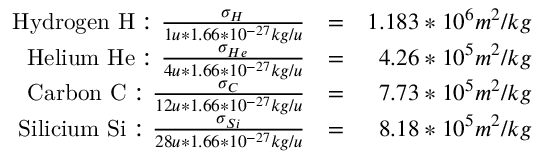Convert formula to latex. <formula><loc_0><loc_0><loc_500><loc_500>\begin{array} { r l r } { H y d r o g e n H \colon \frac { \sigma _ { H } } { 1 u * 1 . 6 6 * 1 0 ^ { - 2 7 } k g / u } } & { = } & { 1 . 1 8 3 * 1 0 ^ { 6 } m ^ { 2 } / k g } \\ { H e l i u m H e \colon \frac { \sigma _ { H e } } { 4 u * 1 . 6 6 * 1 0 ^ { - 2 7 } k g / u } } & { = } & { 4 . 2 6 * 1 0 ^ { 5 } m ^ { 2 } / k g } \\ { C a r b o n C \colon \frac { \sigma _ { C } } { 1 2 u * 1 . 6 6 * 1 0 ^ { - 2 7 } k g / u } } & { = } & { 7 . 7 3 * 1 0 ^ { 5 } m ^ { 2 } / k g } \\ { S i l i c i u m S i \colon \frac { \sigma _ { S i } } { 2 8 u * 1 . 6 6 * 1 0 ^ { - 2 7 } k g / u } } & { = } & { 8 . 1 8 * 1 0 ^ { 5 } m ^ { 2 } / k g } \end{array}</formula> 